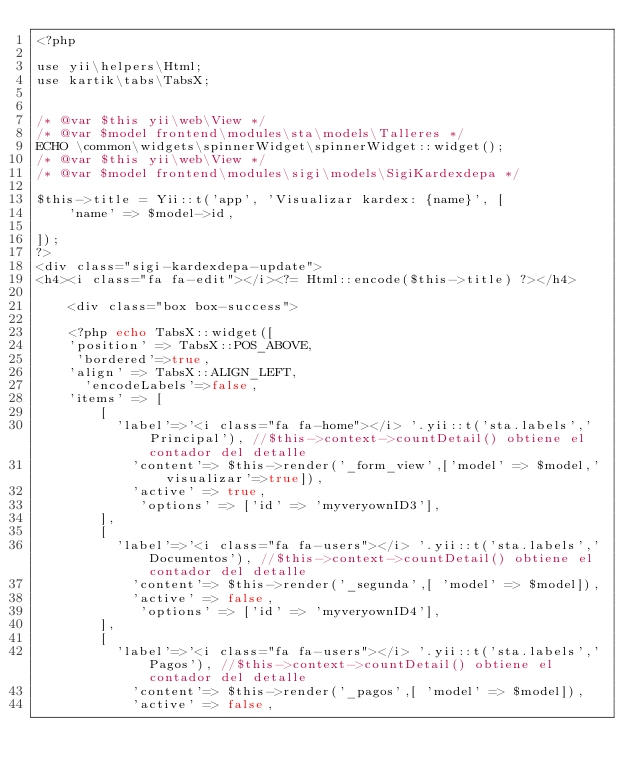Convert code to text. <code><loc_0><loc_0><loc_500><loc_500><_PHP_><?php

use yii\helpers\Html;
use kartik\tabs\TabsX;


/* @var $this yii\web\View */
/* @var $model frontend\modules\sta\models\Talleres */
ECHO \common\widgets\spinnerWidget\spinnerWidget::widget();
/* @var $this yii\web\View */
/* @var $model frontend\modules\sigi\models\SigiKardexdepa */

$this->title = Yii::t('app', 'Visualizar kardex: {name}', [
    'name' => $model->id,
    
]);
?>
<div class="sigi-kardexdepa-update">
<h4><i class="fa fa-edit"></i><?= Html::encode($this->title) ?></h4>
   
    <div class="box box-success">
    
    <?php echo TabsX::widget([
    'position' => TabsX::POS_ABOVE,
     'bordered'=>true,
    'align' => TabsX::ALIGN_LEFT,
      'encodeLabels'=>false,
    'items' => [
        [
          'label'=>'<i class="fa fa-home"></i> '.yii::t('sta.labels','Principal'), //$this->context->countDetail() obtiene el contador del detalle
            'content'=> $this->render('_form_view',['model' => $model,'visualizar'=>true]),
            'active' => true,
             'options' => ['id' => 'myveryownID3'],
        ],
        [
          'label'=>'<i class="fa fa-users"></i> '.yii::t('sta.labels','Documentos'), //$this->context->countDetail() obtiene el contador del detalle
            'content'=> $this->render('_segunda',[ 'model' => $model]),
            'active' => false,
             'options' => ['id' => 'myveryownID4'],
        ],
        [
          'label'=>'<i class="fa fa-users"></i> '.yii::t('sta.labels','Pagos'), //$this->context->countDetail() obtiene el contador del detalle
            'content'=> $this->render('_pagos',[ 'model' => $model]),
            'active' => false,</code> 